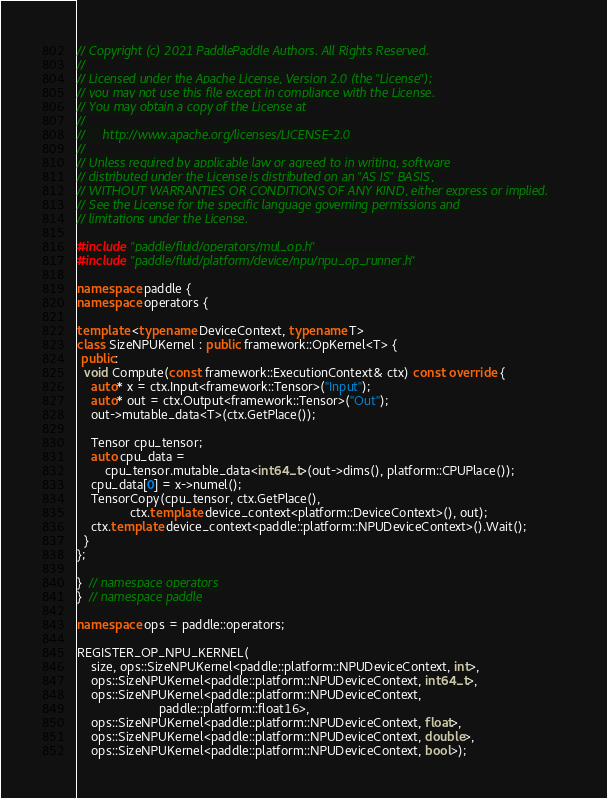Convert code to text. <code><loc_0><loc_0><loc_500><loc_500><_C++_>// Copyright (c) 2021 PaddlePaddle Authors. All Rights Reserved.
//
// Licensed under the Apache License, Version 2.0 (the "License");
// you may not use this file except in compliance with the License.
// You may obtain a copy of the License at
//
//     http://www.apache.org/licenses/LICENSE-2.0
//
// Unless required by applicable law or agreed to in writing, software
// distributed under the License is distributed on an "AS IS" BASIS,
// WITHOUT WARRANTIES OR CONDITIONS OF ANY KIND, either express or implied.
// See the License for the specific language governing permissions and
// limitations under the License.

#include "paddle/fluid/operators/mul_op.h"
#include "paddle/fluid/platform/device/npu/npu_op_runner.h"

namespace paddle {
namespace operators {

template <typename DeviceContext, typename T>
class SizeNPUKernel : public framework::OpKernel<T> {
 public:
  void Compute(const framework::ExecutionContext& ctx) const override {
    auto* x = ctx.Input<framework::Tensor>("Input");
    auto* out = ctx.Output<framework::Tensor>("Out");
    out->mutable_data<T>(ctx.GetPlace());

    Tensor cpu_tensor;
    auto cpu_data =
        cpu_tensor.mutable_data<int64_t>(out->dims(), platform::CPUPlace());
    cpu_data[0] = x->numel();
    TensorCopy(cpu_tensor, ctx.GetPlace(),
               ctx.template device_context<platform::DeviceContext>(), out);
    ctx.template device_context<paddle::platform::NPUDeviceContext>().Wait();
  }
};

}  // namespace operators
}  // namespace paddle

namespace ops = paddle::operators;

REGISTER_OP_NPU_KERNEL(
    size, ops::SizeNPUKernel<paddle::platform::NPUDeviceContext, int>,
    ops::SizeNPUKernel<paddle::platform::NPUDeviceContext, int64_t>,
    ops::SizeNPUKernel<paddle::platform::NPUDeviceContext,
                       paddle::platform::float16>,
    ops::SizeNPUKernel<paddle::platform::NPUDeviceContext, float>,
    ops::SizeNPUKernel<paddle::platform::NPUDeviceContext, double>,
    ops::SizeNPUKernel<paddle::platform::NPUDeviceContext, bool>);
</code> 